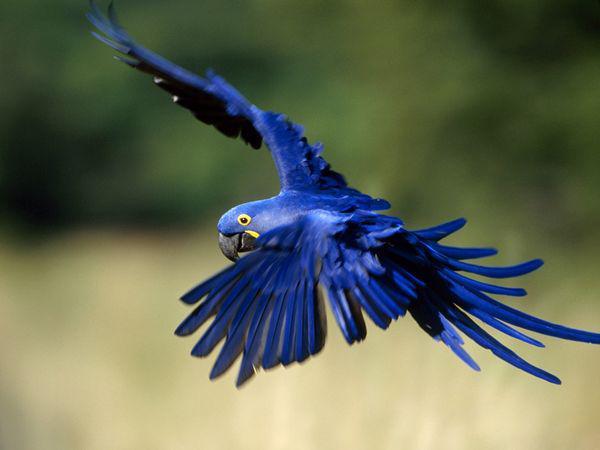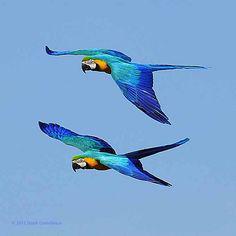The first image is the image on the left, the second image is the image on the right. Assess this claim about the two images: "There is one lone bird flying in one image and two birds flying together in the second.". Correct or not? Answer yes or no. Yes. The first image is the image on the left, the second image is the image on the right. Evaluate the accuracy of this statement regarding the images: "3 parrots are in flight in the image pair". Is it true? Answer yes or no. Yes. 